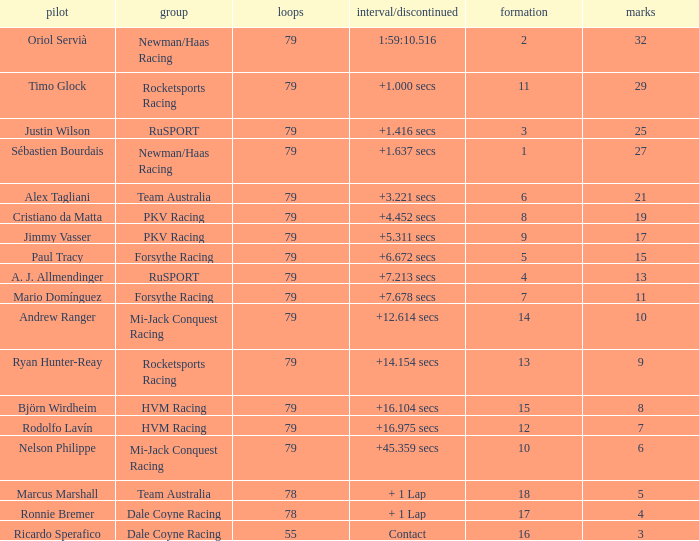What grid has 78 laps, and Ronnie Bremer as driver? 17.0. 